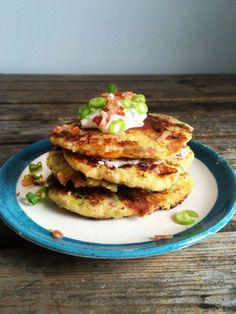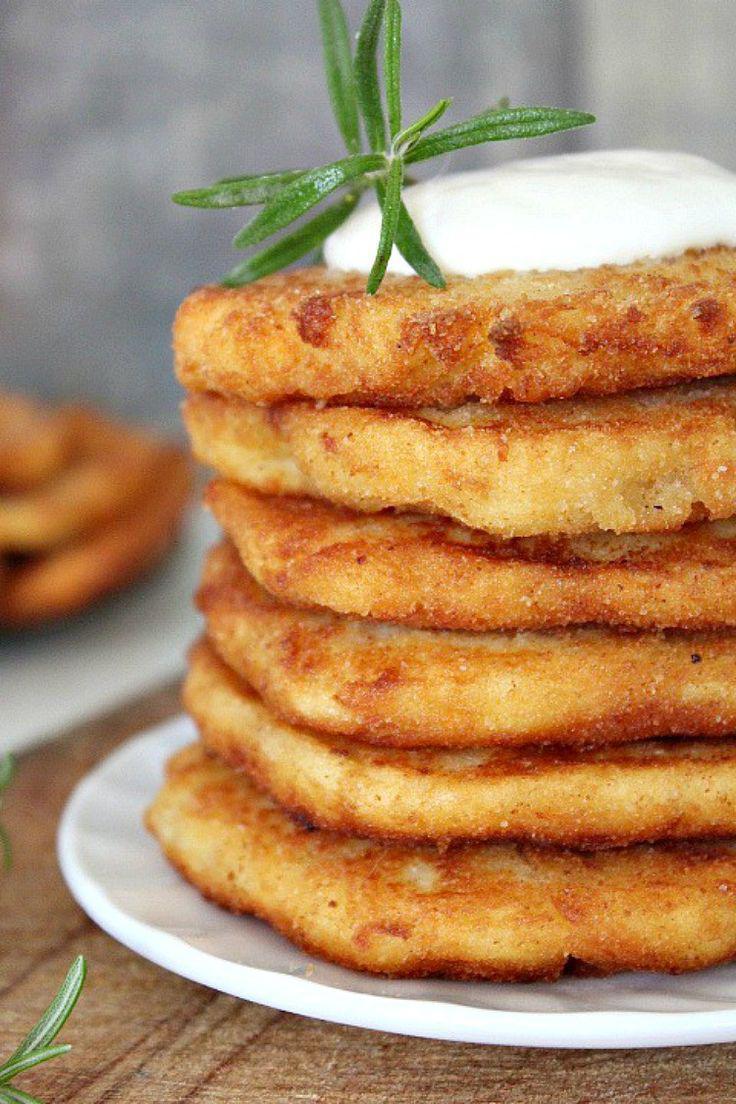The first image is the image on the left, the second image is the image on the right. For the images displayed, is the sentence "One image shows stacked disk shapes garnished with green sprigs, and the other image features something creamy with broccoli florets in it." factually correct? Answer yes or no. No. The first image is the image on the left, the second image is the image on the right. For the images shown, is this caption "At least one of the items is topped with a white sauce." true? Answer yes or no. Yes. 